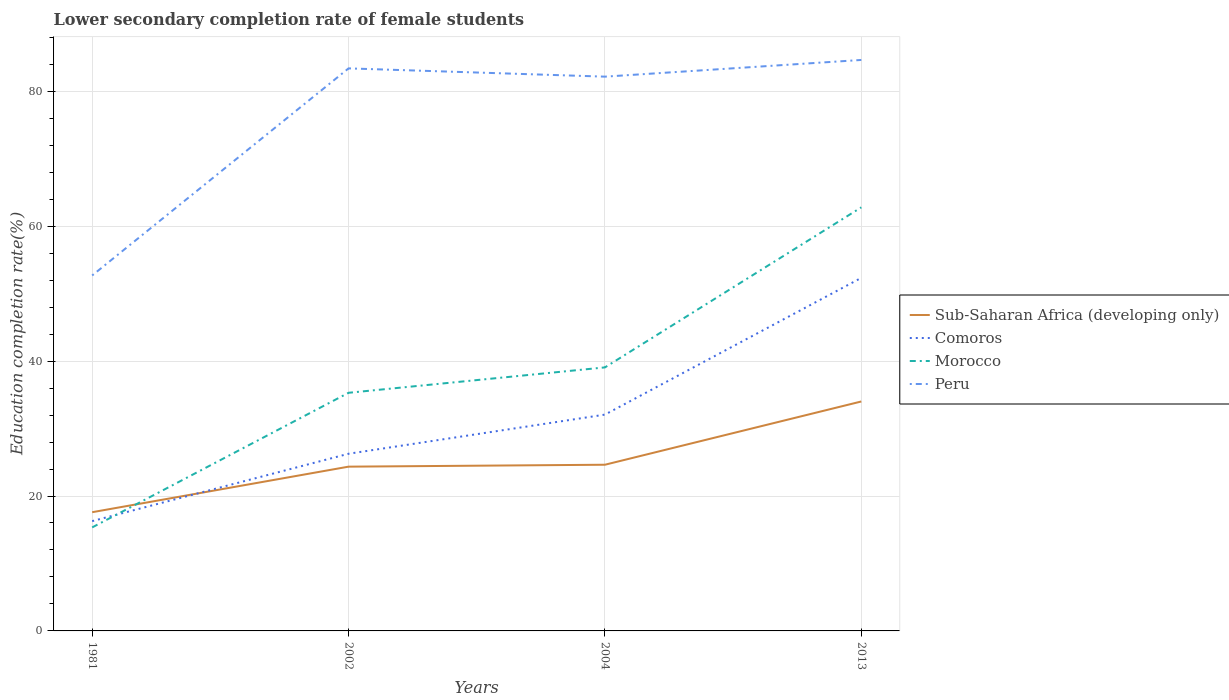Across all years, what is the maximum lower secondary completion rate of female students in Peru?
Offer a terse response. 52.7. In which year was the lower secondary completion rate of female students in Morocco maximum?
Ensure brevity in your answer.  1981. What is the total lower secondary completion rate of female students in Comoros in the graph?
Your answer should be very brief. -9.99. What is the difference between the highest and the second highest lower secondary completion rate of female students in Morocco?
Give a very brief answer. 47.45. How many lines are there?
Give a very brief answer. 4. How many years are there in the graph?
Give a very brief answer. 4. What is the difference between two consecutive major ticks on the Y-axis?
Your response must be concise. 20. Are the values on the major ticks of Y-axis written in scientific E-notation?
Your response must be concise. No. Does the graph contain grids?
Ensure brevity in your answer.  Yes. Where does the legend appear in the graph?
Your response must be concise. Center right. How many legend labels are there?
Your answer should be very brief. 4. How are the legend labels stacked?
Offer a terse response. Vertical. What is the title of the graph?
Make the answer very short. Lower secondary completion rate of female students. Does "Central African Republic" appear as one of the legend labels in the graph?
Your response must be concise. No. What is the label or title of the X-axis?
Make the answer very short. Years. What is the label or title of the Y-axis?
Your answer should be very brief. Education completion rate(%). What is the Education completion rate(%) in Sub-Saharan Africa (developing only) in 1981?
Make the answer very short. 17.6. What is the Education completion rate(%) in Comoros in 1981?
Make the answer very short. 16.28. What is the Education completion rate(%) of Morocco in 1981?
Your answer should be compact. 15.34. What is the Education completion rate(%) of Peru in 1981?
Provide a short and direct response. 52.7. What is the Education completion rate(%) in Sub-Saharan Africa (developing only) in 2002?
Your answer should be compact. 24.35. What is the Education completion rate(%) in Comoros in 2002?
Offer a very short reply. 26.27. What is the Education completion rate(%) in Morocco in 2002?
Your answer should be very brief. 35.3. What is the Education completion rate(%) of Peru in 2002?
Make the answer very short. 83.4. What is the Education completion rate(%) in Sub-Saharan Africa (developing only) in 2004?
Offer a terse response. 24.64. What is the Education completion rate(%) of Comoros in 2004?
Make the answer very short. 32.07. What is the Education completion rate(%) of Morocco in 2004?
Give a very brief answer. 39.07. What is the Education completion rate(%) of Peru in 2004?
Keep it short and to the point. 82.17. What is the Education completion rate(%) of Sub-Saharan Africa (developing only) in 2013?
Offer a terse response. 34.01. What is the Education completion rate(%) in Comoros in 2013?
Give a very brief answer. 52.34. What is the Education completion rate(%) of Morocco in 2013?
Make the answer very short. 62.79. What is the Education completion rate(%) in Peru in 2013?
Offer a very short reply. 84.65. Across all years, what is the maximum Education completion rate(%) of Sub-Saharan Africa (developing only)?
Your answer should be very brief. 34.01. Across all years, what is the maximum Education completion rate(%) of Comoros?
Make the answer very short. 52.34. Across all years, what is the maximum Education completion rate(%) of Morocco?
Your response must be concise. 62.79. Across all years, what is the maximum Education completion rate(%) in Peru?
Offer a very short reply. 84.65. Across all years, what is the minimum Education completion rate(%) of Sub-Saharan Africa (developing only)?
Ensure brevity in your answer.  17.6. Across all years, what is the minimum Education completion rate(%) in Comoros?
Give a very brief answer. 16.28. Across all years, what is the minimum Education completion rate(%) in Morocco?
Ensure brevity in your answer.  15.34. Across all years, what is the minimum Education completion rate(%) in Peru?
Ensure brevity in your answer.  52.7. What is the total Education completion rate(%) in Sub-Saharan Africa (developing only) in the graph?
Your response must be concise. 100.6. What is the total Education completion rate(%) of Comoros in the graph?
Give a very brief answer. 126.95. What is the total Education completion rate(%) of Morocco in the graph?
Your response must be concise. 152.51. What is the total Education completion rate(%) of Peru in the graph?
Provide a succinct answer. 302.91. What is the difference between the Education completion rate(%) in Sub-Saharan Africa (developing only) in 1981 and that in 2002?
Your answer should be very brief. -6.75. What is the difference between the Education completion rate(%) in Comoros in 1981 and that in 2002?
Your response must be concise. -9.99. What is the difference between the Education completion rate(%) in Morocco in 1981 and that in 2002?
Provide a succinct answer. -19.96. What is the difference between the Education completion rate(%) of Peru in 1981 and that in 2002?
Give a very brief answer. -30.7. What is the difference between the Education completion rate(%) of Sub-Saharan Africa (developing only) in 1981 and that in 2004?
Offer a very short reply. -7.04. What is the difference between the Education completion rate(%) of Comoros in 1981 and that in 2004?
Make the answer very short. -15.79. What is the difference between the Education completion rate(%) in Morocco in 1981 and that in 2004?
Your answer should be very brief. -23.72. What is the difference between the Education completion rate(%) in Peru in 1981 and that in 2004?
Your response must be concise. -29.47. What is the difference between the Education completion rate(%) of Sub-Saharan Africa (developing only) in 1981 and that in 2013?
Your answer should be very brief. -16.42. What is the difference between the Education completion rate(%) in Comoros in 1981 and that in 2013?
Offer a terse response. -36.07. What is the difference between the Education completion rate(%) of Morocco in 1981 and that in 2013?
Give a very brief answer. -47.45. What is the difference between the Education completion rate(%) in Peru in 1981 and that in 2013?
Provide a short and direct response. -31.95. What is the difference between the Education completion rate(%) in Sub-Saharan Africa (developing only) in 2002 and that in 2004?
Make the answer very short. -0.29. What is the difference between the Education completion rate(%) in Comoros in 2002 and that in 2004?
Offer a very short reply. -5.8. What is the difference between the Education completion rate(%) of Morocco in 2002 and that in 2004?
Keep it short and to the point. -3.76. What is the difference between the Education completion rate(%) of Peru in 2002 and that in 2004?
Ensure brevity in your answer.  1.23. What is the difference between the Education completion rate(%) of Sub-Saharan Africa (developing only) in 2002 and that in 2013?
Your response must be concise. -9.66. What is the difference between the Education completion rate(%) in Comoros in 2002 and that in 2013?
Provide a short and direct response. -26.08. What is the difference between the Education completion rate(%) in Morocco in 2002 and that in 2013?
Make the answer very short. -27.49. What is the difference between the Education completion rate(%) in Peru in 2002 and that in 2013?
Keep it short and to the point. -1.25. What is the difference between the Education completion rate(%) of Sub-Saharan Africa (developing only) in 2004 and that in 2013?
Give a very brief answer. -9.38. What is the difference between the Education completion rate(%) of Comoros in 2004 and that in 2013?
Your answer should be compact. -20.28. What is the difference between the Education completion rate(%) in Morocco in 2004 and that in 2013?
Your answer should be compact. -23.73. What is the difference between the Education completion rate(%) in Peru in 2004 and that in 2013?
Ensure brevity in your answer.  -2.48. What is the difference between the Education completion rate(%) in Sub-Saharan Africa (developing only) in 1981 and the Education completion rate(%) in Comoros in 2002?
Provide a succinct answer. -8.67. What is the difference between the Education completion rate(%) of Sub-Saharan Africa (developing only) in 1981 and the Education completion rate(%) of Morocco in 2002?
Offer a very short reply. -17.7. What is the difference between the Education completion rate(%) in Sub-Saharan Africa (developing only) in 1981 and the Education completion rate(%) in Peru in 2002?
Make the answer very short. -65.8. What is the difference between the Education completion rate(%) in Comoros in 1981 and the Education completion rate(%) in Morocco in 2002?
Offer a terse response. -19.03. What is the difference between the Education completion rate(%) in Comoros in 1981 and the Education completion rate(%) in Peru in 2002?
Make the answer very short. -67.12. What is the difference between the Education completion rate(%) of Morocco in 1981 and the Education completion rate(%) of Peru in 2002?
Provide a short and direct response. -68.05. What is the difference between the Education completion rate(%) of Sub-Saharan Africa (developing only) in 1981 and the Education completion rate(%) of Comoros in 2004?
Provide a succinct answer. -14.47. What is the difference between the Education completion rate(%) in Sub-Saharan Africa (developing only) in 1981 and the Education completion rate(%) in Morocco in 2004?
Ensure brevity in your answer.  -21.47. What is the difference between the Education completion rate(%) in Sub-Saharan Africa (developing only) in 1981 and the Education completion rate(%) in Peru in 2004?
Make the answer very short. -64.57. What is the difference between the Education completion rate(%) in Comoros in 1981 and the Education completion rate(%) in Morocco in 2004?
Make the answer very short. -22.79. What is the difference between the Education completion rate(%) of Comoros in 1981 and the Education completion rate(%) of Peru in 2004?
Your answer should be compact. -65.89. What is the difference between the Education completion rate(%) of Morocco in 1981 and the Education completion rate(%) of Peru in 2004?
Keep it short and to the point. -66.82. What is the difference between the Education completion rate(%) in Sub-Saharan Africa (developing only) in 1981 and the Education completion rate(%) in Comoros in 2013?
Provide a succinct answer. -34.74. What is the difference between the Education completion rate(%) in Sub-Saharan Africa (developing only) in 1981 and the Education completion rate(%) in Morocco in 2013?
Provide a short and direct response. -45.2. What is the difference between the Education completion rate(%) in Sub-Saharan Africa (developing only) in 1981 and the Education completion rate(%) in Peru in 2013?
Make the answer very short. -67.05. What is the difference between the Education completion rate(%) of Comoros in 1981 and the Education completion rate(%) of Morocco in 2013?
Give a very brief answer. -46.52. What is the difference between the Education completion rate(%) in Comoros in 1981 and the Education completion rate(%) in Peru in 2013?
Ensure brevity in your answer.  -68.37. What is the difference between the Education completion rate(%) in Morocco in 1981 and the Education completion rate(%) in Peru in 2013?
Give a very brief answer. -69.3. What is the difference between the Education completion rate(%) of Sub-Saharan Africa (developing only) in 2002 and the Education completion rate(%) of Comoros in 2004?
Offer a terse response. -7.71. What is the difference between the Education completion rate(%) in Sub-Saharan Africa (developing only) in 2002 and the Education completion rate(%) in Morocco in 2004?
Ensure brevity in your answer.  -14.71. What is the difference between the Education completion rate(%) in Sub-Saharan Africa (developing only) in 2002 and the Education completion rate(%) in Peru in 2004?
Give a very brief answer. -57.82. What is the difference between the Education completion rate(%) of Comoros in 2002 and the Education completion rate(%) of Morocco in 2004?
Ensure brevity in your answer.  -12.8. What is the difference between the Education completion rate(%) in Comoros in 2002 and the Education completion rate(%) in Peru in 2004?
Your answer should be very brief. -55.9. What is the difference between the Education completion rate(%) in Morocco in 2002 and the Education completion rate(%) in Peru in 2004?
Provide a succinct answer. -46.87. What is the difference between the Education completion rate(%) of Sub-Saharan Africa (developing only) in 2002 and the Education completion rate(%) of Comoros in 2013?
Your response must be concise. -27.99. What is the difference between the Education completion rate(%) in Sub-Saharan Africa (developing only) in 2002 and the Education completion rate(%) in Morocco in 2013?
Provide a succinct answer. -38.44. What is the difference between the Education completion rate(%) of Sub-Saharan Africa (developing only) in 2002 and the Education completion rate(%) of Peru in 2013?
Provide a short and direct response. -60.29. What is the difference between the Education completion rate(%) in Comoros in 2002 and the Education completion rate(%) in Morocco in 2013?
Offer a terse response. -36.53. What is the difference between the Education completion rate(%) in Comoros in 2002 and the Education completion rate(%) in Peru in 2013?
Your response must be concise. -58.38. What is the difference between the Education completion rate(%) in Morocco in 2002 and the Education completion rate(%) in Peru in 2013?
Provide a short and direct response. -49.34. What is the difference between the Education completion rate(%) in Sub-Saharan Africa (developing only) in 2004 and the Education completion rate(%) in Comoros in 2013?
Ensure brevity in your answer.  -27.71. What is the difference between the Education completion rate(%) in Sub-Saharan Africa (developing only) in 2004 and the Education completion rate(%) in Morocco in 2013?
Your answer should be compact. -38.16. What is the difference between the Education completion rate(%) in Sub-Saharan Africa (developing only) in 2004 and the Education completion rate(%) in Peru in 2013?
Give a very brief answer. -60.01. What is the difference between the Education completion rate(%) of Comoros in 2004 and the Education completion rate(%) of Morocco in 2013?
Give a very brief answer. -30.73. What is the difference between the Education completion rate(%) in Comoros in 2004 and the Education completion rate(%) in Peru in 2013?
Offer a terse response. -52.58. What is the difference between the Education completion rate(%) of Morocco in 2004 and the Education completion rate(%) of Peru in 2013?
Provide a short and direct response. -45.58. What is the average Education completion rate(%) in Sub-Saharan Africa (developing only) per year?
Give a very brief answer. 25.15. What is the average Education completion rate(%) of Comoros per year?
Your answer should be very brief. 31.74. What is the average Education completion rate(%) in Morocco per year?
Provide a succinct answer. 38.13. What is the average Education completion rate(%) of Peru per year?
Make the answer very short. 75.73. In the year 1981, what is the difference between the Education completion rate(%) of Sub-Saharan Africa (developing only) and Education completion rate(%) of Comoros?
Offer a very short reply. 1.32. In the year 1981, what is the difference between the Education completion rate(%) of Sub-Saharan Africa (developing only) and Education completion rate(%) of Morocco?
Ensure brevity in your answer.  2.25. In the year 1981, what is the difference between the Education completion rate(%) in Sub-Saharan Africa (developing only) and Education completion rate(%) in Peru?
Provide a succinct answer. -35.1. In the year 1981, what is the difference between the Education completion rate(%) of Comoros and Education completion rate(%) of Peru?
Offer a very short reply. -36.42. In the year 1981, what is the difference between the Education completion rate(%) in Morocco and Education completion rate(%) in Peru?
Provide a short and direct response. -37.35. In the year 2002, what is the difference between the Education completion rate(%) of Sub-Saharan Africa (developing only) and Education completion rate(%) of Comoros?
Provide a succinct answer. -1.91. In the year 2002, what is the difference between the Education completion rate(%) in Sub-Saharan Africa (developing only) and Education completion rate(%) in Morocco?
Ensure brevity in your answer.  -10.95. In the year 2002, what is the difference between the Education completion rate(%) of Sub-Saharan Africa (developing only) and Education completion rate(%) of Peru?
Offer a terse response. -59.04. In the year 2002, what is the difference between the Education completion rate(%) in Comoros and Education completion rate(%) in Morocco?
Make the answer very short. -9.04. In the year 2002, what is the difference between the Education completion rate(%) in Comoros and Education completion rate(%) in Peru?
Offer a very short reply. -57.13. In the year 2002, what is the difference between the Education completion rate(%) in Morocco and Education completion rate(%) in Peru?
Give a very brief answer. -48.09. In the year 2004, what is the difference between the Education completion rate(%) of Sub-Saharan Africa (developing only) and Education completion rate(%) of Comoros?
Ensure brevity in your answer.  -7.43. In the year 2004, what is the difference between the Education completion rate(%) in Sub-Saharan Africa (developing only) and Education completion rate(%) in Morocco?
Ensure brevity in your answer.  -14.43. In the year 2004, what is the difference between the Education completion rate(%) in Sub-Saharan Africa (developing only) and Education completion rate(%) in Peru?
Keep it short and to the point. -57.53. In the year 2004, what is the difference between the Education completion rate(%) of Comoros and Education completion rate(%) of Morocco?
Offer a terse response. -7. In the year 2004, what is the difference between the Education completion rate(%) in Comoros and Education completion rate(%) in Peru?
Your answer should be very brief. -50.1. In the year 2004, what is the difference between the Education completion rate(%) in Morocco and Education completion rate(%) in Peru?
Offer a terse response. -43.1. In the year 2013, what is the difference between the Education completion rate(%) in Sub-Saharan Africa (developing only) and Education completion rate(%) in Comoros?
Ensure brevity in your answer.  -18.33. In the year 2013, what is the difference between the Education completion rate(%) in Sub-Saharan Africa (developing only) and Education completion rate(%) in Morocco?
Offer a very short reply. -28.78. In the year 2013, what is the difference between the Education completion rate(%) of Sub-Saharan Africa (developing only) and Education completion rate(%) of Peru?
Provide a succinct answer. -50.63. In the year 2013, what is the difference between the Education completion rate(%) of Comoros and Education completion rate(%) of Morocco?
Offer a terse response. -10.45. In the year 2013, what is the difference between the Education completion rate(%) of Comoros and Education completion rate(%) of Peru?
Provide a short and direct response. -32.3. In the year 2013, what is the difference between the Education completion rate(%) in Morocco and Education completion rate(%) in Peru?
Offer a very short reply. -21.85. What is the ratio of the Education completion rate(%) of Sub-Saharan Africa (developing only) in 1981 to that in 2002?
Your answer should be compact. 0.72. What is the ratio of the Education completion rate(%) in Comoros in 1981 to that in 2002?
Offer a terse response. 0.62. What is the ratio of the Education completion rate(%) in Morocco in 1981 to that in 2002?
Ensure brevity in your answer.  0.43. What is the ratio of the Education completion rate(%) in Peru in 1981 to that in 2002?
Your answer should be very brief. 0.63. What is the ratio of the Education completion rate(%) in Sub-Saharan Africa (developing only) in 1981 to that in 2004?
Make the answer very short. 0.71. What is the ratio of the Education completion rate(%) in Comoros in 1981 to that in 2004?
Give a very brief answer. 0.51. What is the ratio of the Education completion rate(%) of Morocco in 1981 to that in 2004?
Keep it short and to the point. 0.39. What is the ratio of the Education completion rate(%) in Peru in 1981 to that in 2004?
Your answer should be very brief. 0.64. What is the ratio of the Education completion rate(%) in Sub-Saharan Africa (developing only) in 1981 to that in 2013?
Your answer should be very brief. 0.52. What is the ratio of the Education completion rate(%) in Comoros in 1981 to that in 2013?
Provide a succinct answer. 0.31. What is the ratio of the Education completion rate(%) of Morocco in 1981 to that in 2013?
Offer a very short reply. 0.24. What is the ratio of the Education completion rate(%) of Peru in 1981 to that in 2013?
Ensure brevity in your answer.  0.62. What is the ratio of the Education completion rate(%) of Sub-Saharan Africa (developing only) in 2002 to that in 2004?
Provide a short and direct response. 0.99. What is the ratio of the Education completion rate(%) of Comoros in 2002 to that in 2004?
Give a very brief answer. 0.82. What is the ratio of the Education completion rate(%) of Morocco in 2002 to that in 2004?
Your response must be concise. 0.9. What is the ratio of the Education completion rate(%) of Peru in 2002 to that in 2004?
Provide a succinct answer. 1.01. What is the ratio of the Education completion rate(%) in Sub-Saharan Africa (developing only) in 2002 to that in 2013?
Your response must be concise. 0.72. What is the ratio of the Education completion rate(%) in Comoros in 2002 to that in 2013?
Offer a terse response. 0.5. What is the ratio of the Education completion rate(%) of Morocco in 2002 to that in 2013?
Offer a very short reply. 0.56. What is the ratio of the Education completion rate(%) of Peru in 2002 to that in 2013?
Offer a very short reply. 0.99. What is the ratio of the Education completion rate(%) in Sub-Saharan Africa (developing only) in 2004 to that in 2013?
Keep it short and to the point. 0.72. What is the ratio of the Education completion rate(%) of Comoros in 2004 to that in 2013?
Keep it short and to the point. 0.61. What is the ratio of the Education completion rate(%) in Morocco in 2004 to that in 2013?
Offer a very short reply. 0.62. What is the ratio of the Education completion rate(%) in Peru in 2004 to that in 2013?
Provide a short and direct response. 0.97. What is the difference between the highest and the second highest Education completion rate(%) in Sub-Saharan Africa (developing only)?
Provide a short and direct response. 9.38. What is the difference between the highest and the second highest Education completion rate(%) in Comoros?
Offer a very short reply. 20.28. What is the difference between the highest and the second highest Education completion rate(%) in Morocco?
Your answer should be compact. 23.73. What is the difference between the highest and the second highest Education completion rate(%) in Peru?
Keep it short and to the point. 1.25. What is the difference between the highest and the lowest Education completion rate(%) of Sub-Saharan Africa (developing only)?
Ensure brevity in your answer.  16.42. What is the difference between the highest and the lowest Education completion rate(%) in Comoros?
Your response must be concise. 36.07. What is the difference between the highest and the lowest Education completion rate(%) in Morocco?
Your response must be concise. 47.45. What is the difference between the highest and the lowest Education completion rate(%) in Peru?
Make the answer very short. 31.95. 